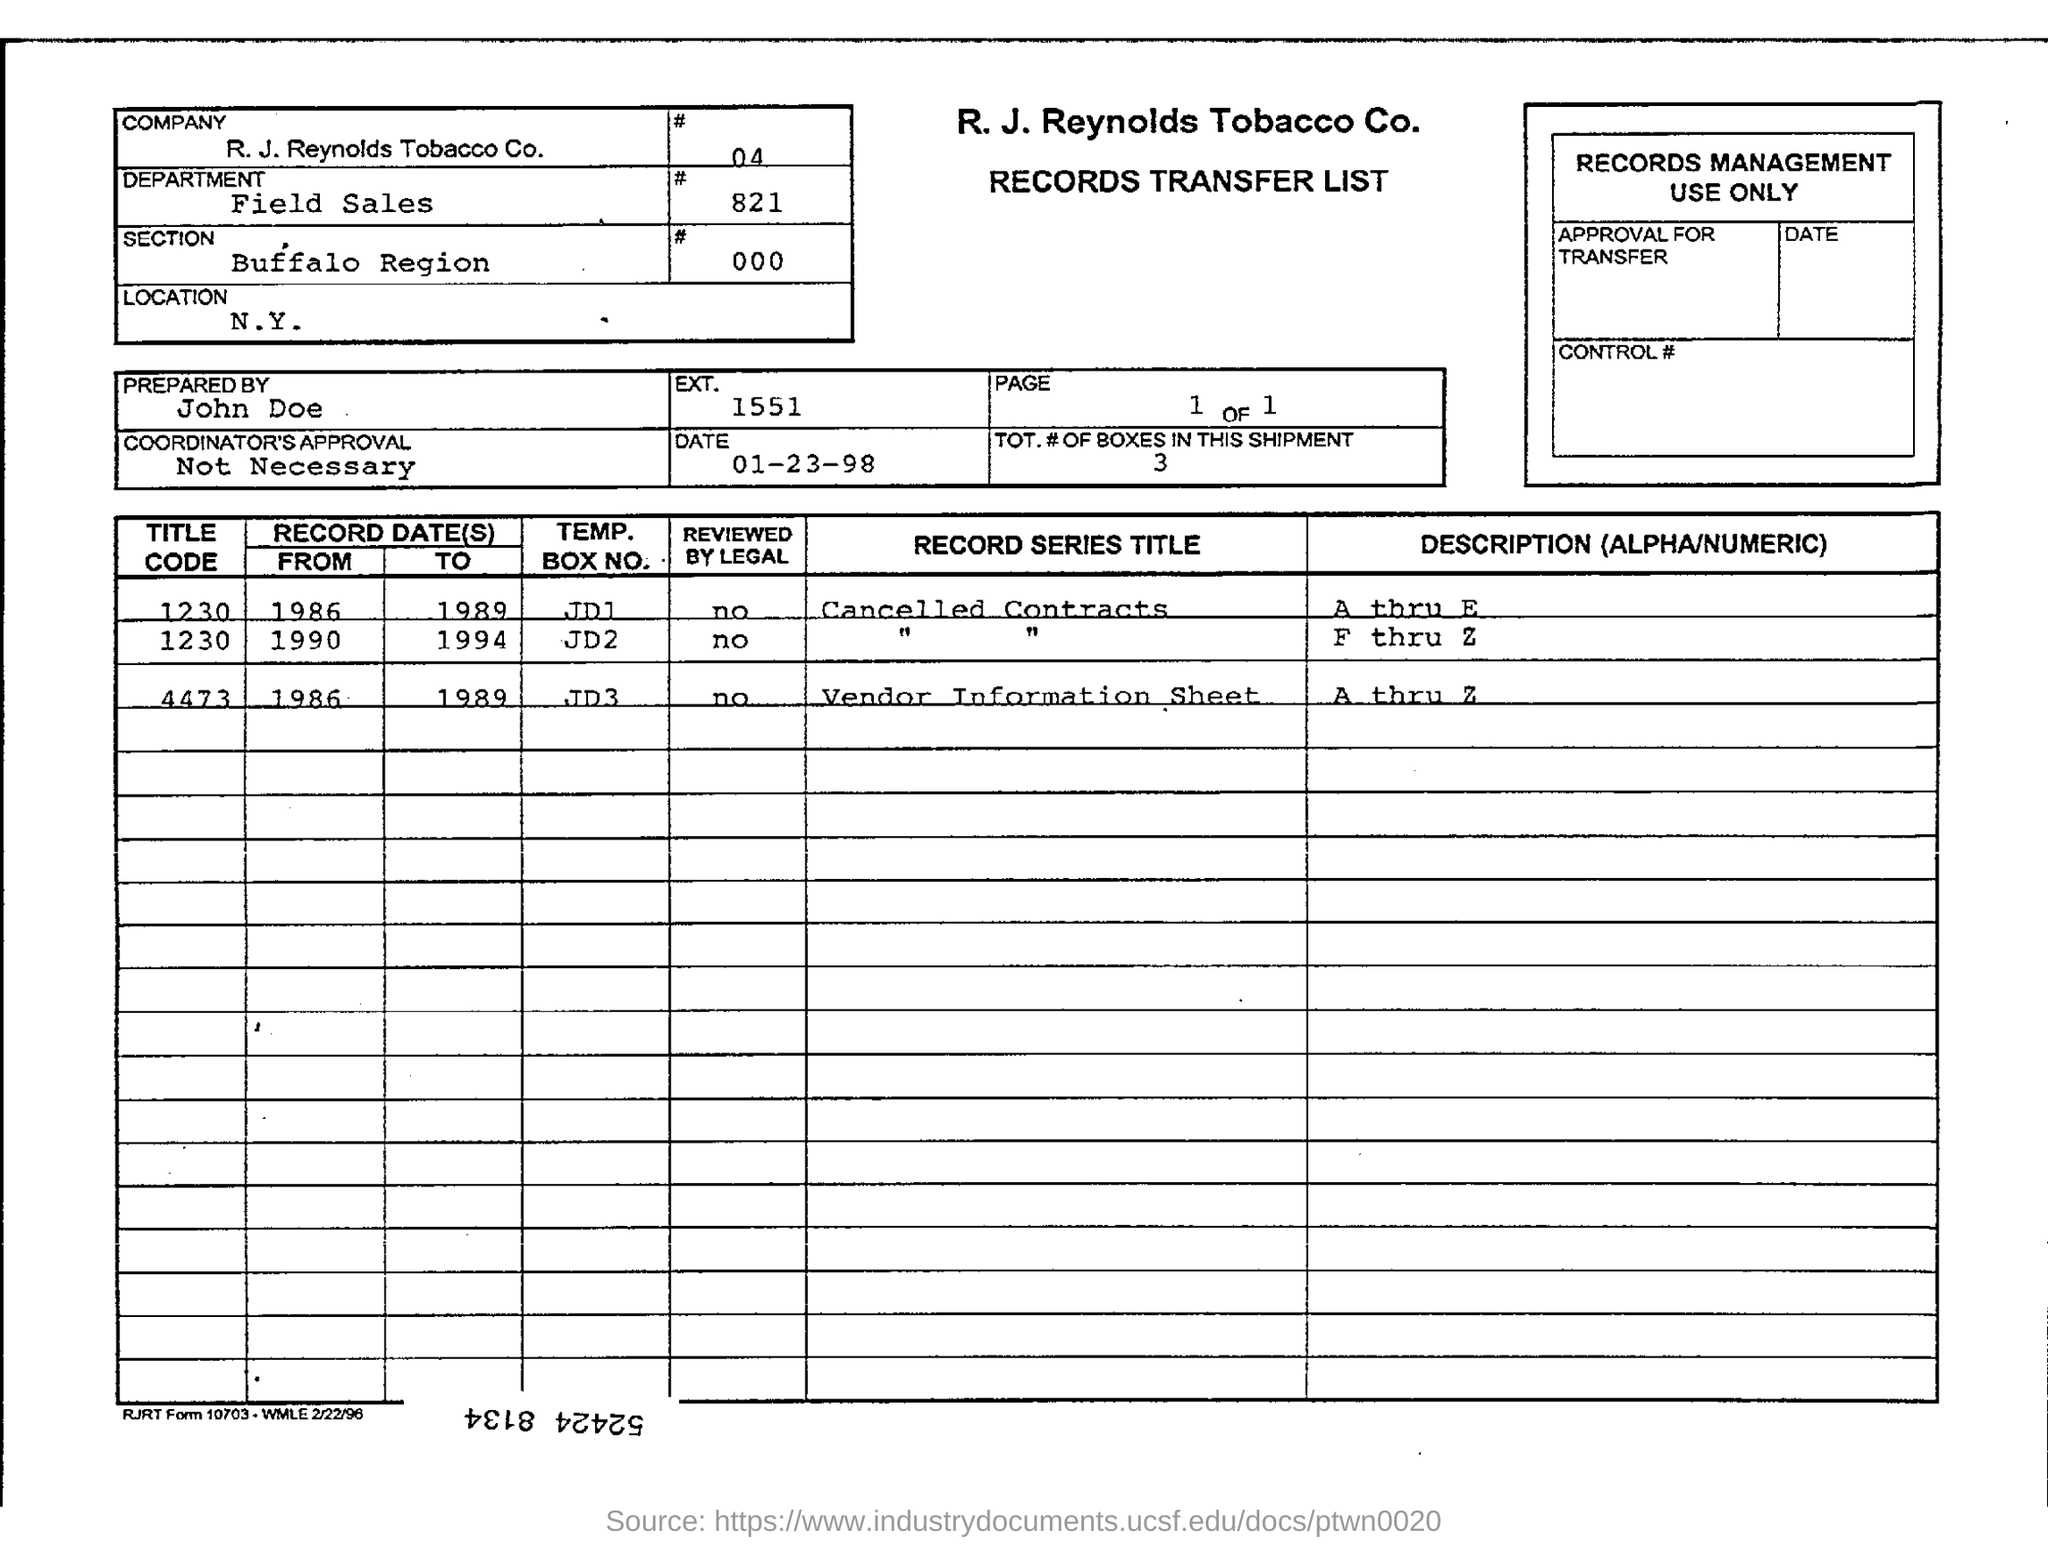What is the Company mentioned in the form?
Offer a terse response. R. J. Reynolds Tobacco Co. What is the Department?
Give a very brief answer. Field Sales. What is the Section?
Give a very brief answer. Buffalo region. Who is it prepared by?
Provide a succinct answer. John doe. What is the Location?
Offer a very short reply. N.Y. What is the date on the document?
Give a very brief answer. 01-23-98. 